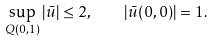Convert formula to latex. <formula><loc_0><loc_0><loc_500><loc_500>\sup _ { Q ( 0 , 1 ) } | \bar { u } | \leq 2 , \quad | \bar { u } ( 0 , 0 ) | = 1 .</formula> 